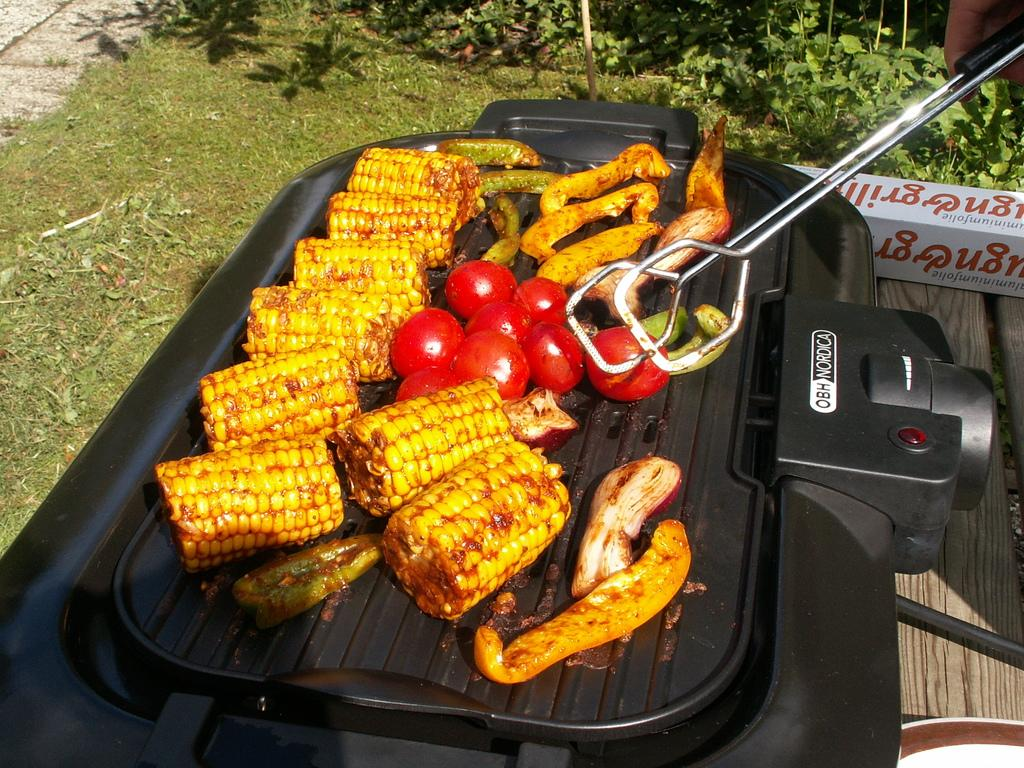<image>
Provide a brief description of the given image. The OBH Nordica is a model of outdoor grill that can be used for meats and vegetables. 